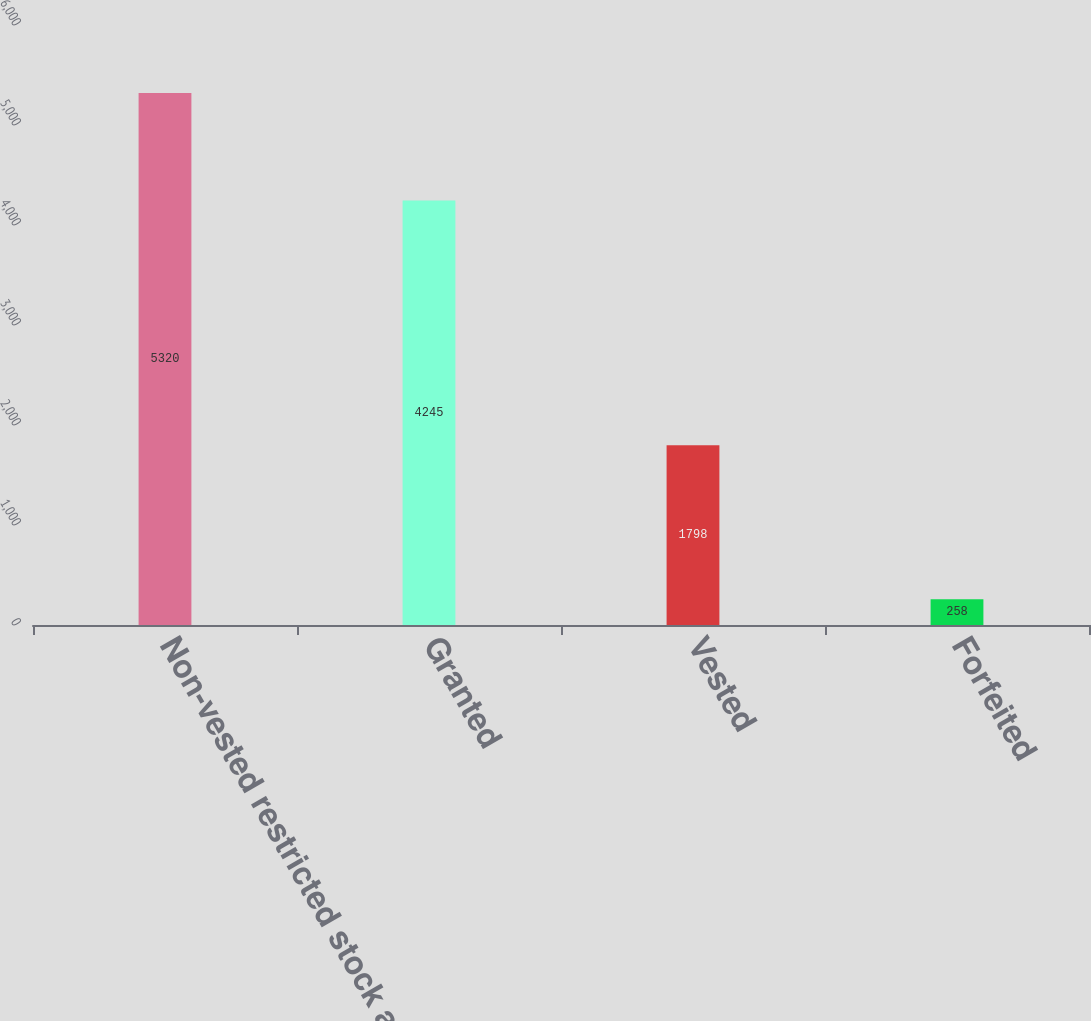<chart> <loc_0><loc_0><loc_500><loc_500><bar_chart><fcel>Non-vested restricted stock at<fcel>Granted<fcel>Vested<fcel>Forfeited<nl><fcel>5320<fcel>4245<fcel>1798<fcel>258<nl></chart> 